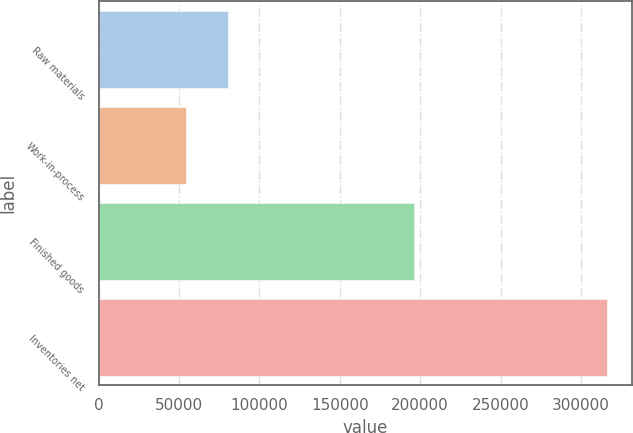<chart> <loc_0><loc_0><loc_500><loc_500><bar_chart><fcel>Raw materials<fcel>Work-in-process<fcel>Finished goods<fcel>Inventories net<nl><fcel>80716.6<fcel>54555<fcel>196297<fcel>316171<nl></chart> 